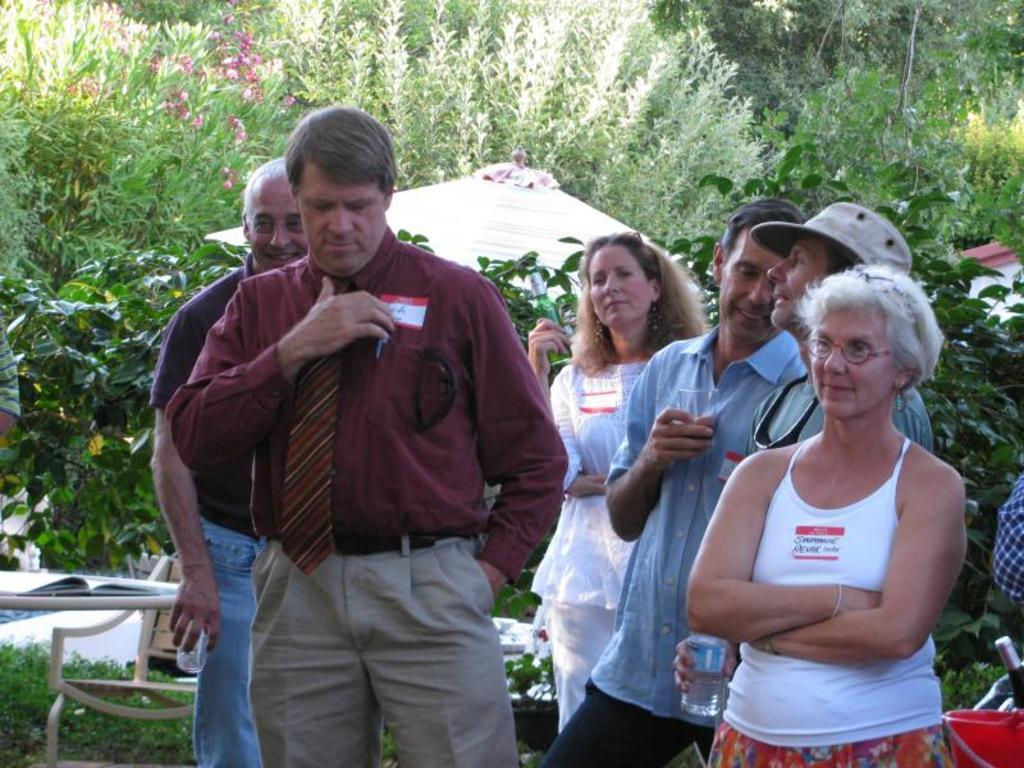How many people are in the image? There is a group of people in the image, but the exact number cannot be determined from the provided facts. What can be seen in the background of the image? There are trees in the background of the image. What type of yam is being served to the queen in the image? There is no queen or yam present in the image; it features a group of people and trees in the background. 